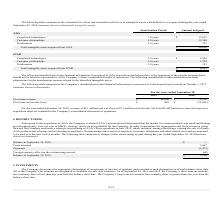According to Mitek Systems's financial document, What does the table provide for us? the Company’s unaudited pro forma financial information is presented as if the acquisitions occurred on October 1, 2017. The document states: "The following table summarizes the Company’s unaudited pro forma financial information is presented as if the acquisitions occurred on October 1, 2017..." Also, What are the revenue and net loss related to the A2iA and ICAR businesses for the year ended September 30, 2018, respectively? The document shows two values: $9.1 million and $5.3 million. From the document: "For the year ended September 30, 2018, revenue of $9.1 million and a net loss of $5.3 million related to the A2iA and ICAR businesses since the respec..." Also, What are the pro forma revenues in 2018 and 2019, respectively? The document shows two values: $86,206 and $78,130 (in thousands). From the document: "Pro forma revenue $ 86,206 $ 78,130 Pro forma revenue $ 86,206 $ 78,130..." Also, can you calculate: What is the percentage change in pro forma revenue from 2018 to 2019?  To answer this question, I need to perform calculations using the financial data. The calculation is: (86,206-78,130)/78,130 , which equals 10.34 (percentage). This is based on the information: "Pro forma revenue $ 86,206 $ 78,130 Pro forma revenue $ 86,206 $ 78,130..." The key data points involved are: 78,130, 86,206. Also, can you calculate: What is the average pro forma net income (loss) for the last 2 years, i.e. 2018 and 2019? To answer this question, I need to perform calculations using the financial data. The calculation is: (889+(-12,268))/2 , which equals -5689.5 (in thousands). This is based on the information: "Pro forma net income (loss) $ 889 $ (12,268) Pro forma net income (loss) $ 889 $ (12,268) Pro forma net income (loss) $ 889 $ (12,268)..." The key data points involved are: 12,268, 2, 889. Additionally, Which year has a higher amount of pro forma revenue? According to the financial document, 2019. The relevant text states: "2019 2018..." 